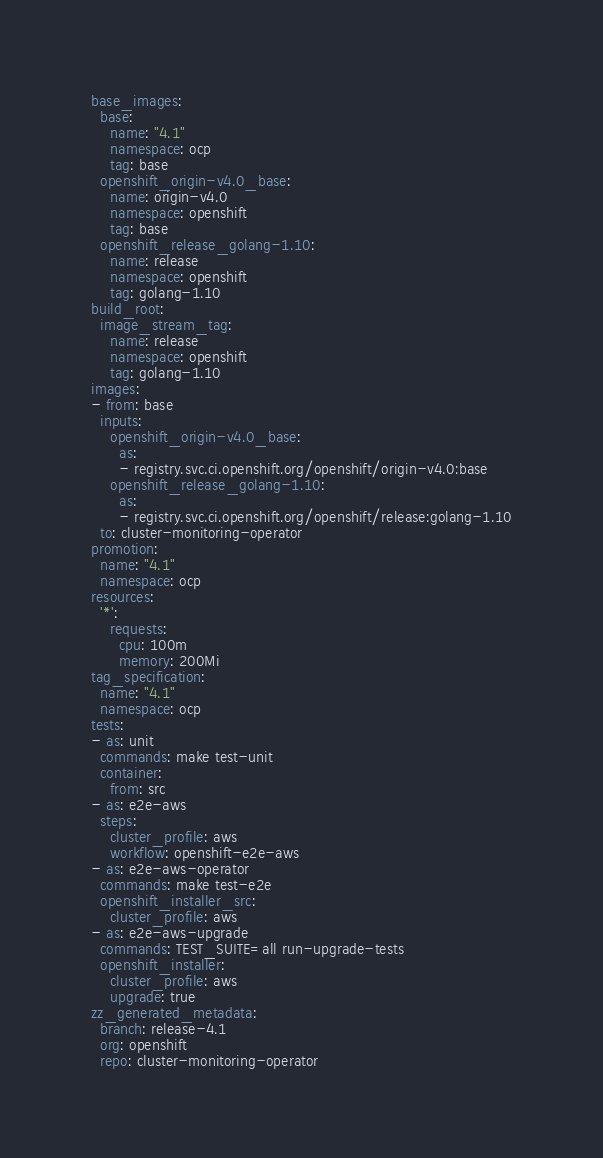Convert code to text. <code><loc_0><loc_0><loc_500><loc_500><_YAML_>base_images:
  base:
    name: "4.1"
    namespace: ocp
    tag: base
  openshift_origin-v4.0_base:
    name: origin-v4.0
    namespace: openshift
    tag: base
  openshift_release_golang-1.10:
    name: release
    namespace: openshift
    tag: golang-1.10
build_root:
  image_stream_tag:
    name: release
    namespace: openshift
    tag: golang-1.10
images:
- from: base
  inputs:
    openshift_origin-v4.0_base:
      as:
      - registry.svc.ci.openshift.org/openshift/origin-v4.0:base
    openshift_release_golang-1.10:
      as:
      - registry.svc.ci.openshift.org/openshift/release:golang-1.10
  to: cluster-monitoring-operator
promotion:
  name: "4.1"
  namespace: ocp
resources:
  '*':
    requests:
      cpu: 100m
      memory: 200Mi
tag_specification:
  name: "4.1"
  namespace: ocp
tests:
- as: unit
  commands: make test-unit
  container:
    from: src
- as: e2e-aws
  steps:
    cluster_profile: aws
    workflow: openshift-e2e-aws
- as: e2e-aws-operator
  commands: make test-e2e
  openshift_installer_src:
    cluster_profile: aws
- as: e2e-aws-upgrade
  commands: TEST_SUITE=all run-upgrade-tests
  openshift_installer:
    cluster_profile: aws
    upgrade: true
zz_generated_metadata:
  branch: release-4.1
  org: openshift
  repo: cluster-monitoring-operator
</code> 